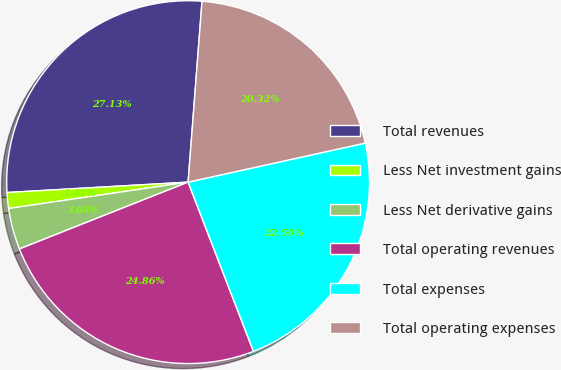<chart> <loc_0><loc_0><loc_500><loc_500><pie_chart><fcel>Total revenues<fcel>Less Net investment gains<fcel>Less Net derivative gains<fcel>Total operating revenues<fcel>Total expenses<fcel>Total operating expenses<nl><fcel>27.13%<fcel>1.41%<fcel>3.68%<fcel>24.86%<fcel>22.59%<fcel>20.32%<nl></chart> 